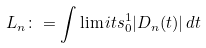Convert formula to latex. <formula><loc_0><loc_0><loc_500><loc_500>L _ { n } \colon = \int \lim i t s _ { 0 } ^ { 1 } | D _ { n } ( t ) | \, d t</formula> 